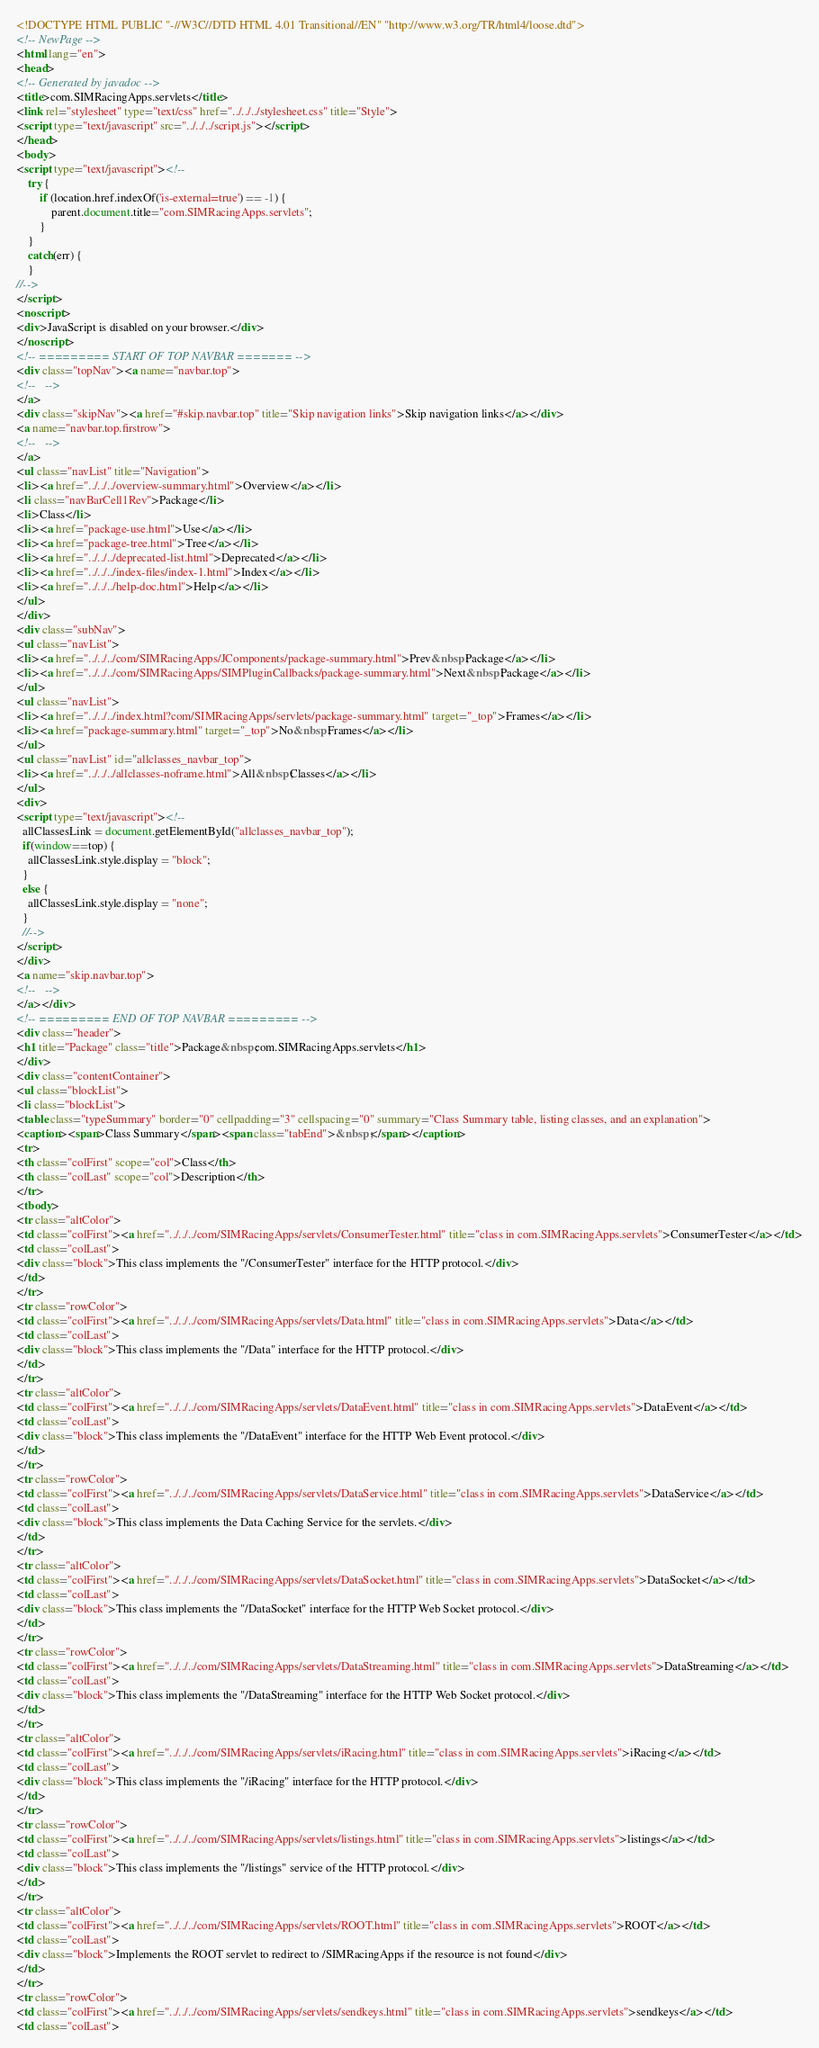Convert code to text. <code><loc_0><loc_0><loc_500><loc_500><_HTML_><!DOCTYPE HTML PUBLIC "-//W3C//DTD HTML 4.01 Transitional//EN" "http://www.w3.org/TR/html4/loose.dtd">
<!-- NewPage -->
<html lang="en">
<head>
<!-- Generated by javadoc -->
<title>com.SIMRacingApps.servlets</title>
<link rel="stylesheet" type="text/css" href="../../../stylesheet.css" title="Style">
<script type="text/javascript" src="../../../script.js"></script>
</head>
<body>
<script type="text/javascript"><!--
    try {
        if (location.href.indexOf('is-external=true') == -1) {
            parent.document.title="com.SIMRacingApps.servlets";
        }
    }
    catch(err) {
    }
//-->
</script>
<noscript>
<div>JavaScript is disabled on your browser.</div>
</noscript>
<!-- ========= START OF TOP NAVBAR ======= -->
<div class="topNav"><a name="navbar.top">
<!--   -->
</a>
<div class="skipNav"><a href="#skip.navbar.top" title="Skip navigation links">Skip navigation links</a></div>
<a name="navbar.top.firstrow">
<!--   -->
</a>
<ul class="navList" title="Navigation">
<li><a href="../../../overview-summary.html">Overview</a></li>
<li class="navBarCell1Rev">Package</li>
<li>Class</li>
<li><a href="package-use.html">Use</a></li>
<li><a href="package-tree.html">Tree</a></li>
<li><a href="../../../deprecated-list.html">Deprecated</a></li>
<li><a href="../../../index-files/index-1.html">Index</a></li>
<li><a href="../../../help-doc.html">Help</a></li>
</ul>
</div>
<div class="subNav">
<ul class="navList">
<li><a href="../../../com/SIMRacingApps/JComponents/package-summary.html">Prev&nbsp;Package</a></li>
<li><a href="../../../com/SIMRacingApps/SIMPluginCallbacks/package-summary.html">Next&nbsp;Package</a></li>
</ul>
<ul class="navList">
<li><a href="../../../index.html?com/SIMRacingApps/servlets/package-summary.html" target="_top">Frames</a></li>
<li><a href="package-summary.html" target="_top">No&nbsp;Frames</a></li>
</ul>
<ul class="navList" id="allclasses_navbar_top">
<li><a href="../../../allclasses-noframe.html">All&nbsp;Classes</a></li>
</ul>
<div>
<script type="text/javascript"><!--
  allClassesLink = document.getElementById("allclasses_navbar_top");
  if(window==top) {
    allClassesLink.style.display = "block";
  }
  else {
    allClassesLink.style.display = "none";
  }
  //-->
</script>
</div>
<a name="skip.navbar.top">
<!--   -->
</a></div>
<!-- ========= END OF TOP NAVBAR ========= -->
<div class="header">
<h1 title="Package" class="title">Package&nbsp;com.SIMRacingApps.servlets</h1>
</div>
<div class="contentContainer">
<ul class="blockList">
<li class="blockList">
<table class="typeSummary" border="0" cellpadding="3" cellspacing="0" summary="Class Summary table, listing classes, and an explanation">
<caption><span>Class Summary</span><span class="tabEnd">&nbsp;</span></caption>
<tr>
<th class="colFirst" scope="col">Class</th>
<th class="colLast" scope="col">Description</th>
</tr>
<tbody>
<tr class="altColor">
<td class="colFirst"><a href="../../../com/SIMRacingApps/servlets/ConsumerTester.html" title="class in com.SIMRacingApps.servlets">ConsumerTester</a></td>
<td class="colLast">
<div class="block">This class implements the "/ConsumerTester" interface for the HTTP protocol.</div>
</td>
</tr>
<tr class="rowColor">
<td class="colFirst"><a href="../../../com/SIMRacingApps/servlets/Data.html" title="class in com.SIMRacingApps.servlets">Data</a></td>
<td class="colLast">
<div class="block">This class implements the "/Data" interface for the HTTP protocol.</div>
</td>
</tr>
<tr class="altColor">
<td class="colFirst"><a href="../../../com/SIMRacingApps/servlets/DataEvent.html" title="class in com.SIMRacingApps.servlets">DataEvent</a></td>
<td class="colLast">
<div class="block">This class implements the "/DataEvent" interface for the HTTP Web Event protocol.</div>
</td>
</tr>
<tr class="rowColor">
<td class="colFirst"><a href="../../../com/SIMRacingApps/servlets/DataService.html" title="class in com.SIMRacingApps.servlets">DataService</a></td>
<td class="colLast">
<div class="block">This class implements the Data Caching Service for the servlets.</div>
</td>
</tr>
<tr class="altColor">
<td class="colFirst"><a href="../../../com/SIMRacingApps/servlets/DataSocket.html" title="class in com.SIMRacingApps.servlets">DataSocket</a></td>
<td class="colLast">
<div class="block">This class implements the "/DataSocket" interface for the HTTP Web Socket protocol.</div>
</td>
</tr>
<tr class="rowColor">
<td class="colFirst"><a href="../../../com/SIMRacingApps/servlets/DataStreaming.html" title="class in com.SIMRacingApps.servlets">DataStreaming</a></td>
<td class="colLast">
<div class="block">This class implements the "/DataStreaming" interface for the HTTP Web Socket protocol.</div>
</td>
</tr>
<tr class="altColor">
<td class="colFirst"><a href="../../../com/SIMRacingApps/servlets/iRacing.html" title="class in com.SIMRacingApps.servlets">iRacing</a></td>
<td class="colLast">
<div class="block">This class implements the "/iRacing" interface for the HTTP protocol.</div>
</td>
</tr>
<tr class="rowColor">
<td class="colFirst"><a href="../../../com/SIMRacingApps/servlets/listings.html" title="class in com.SIMRacingApps.servlets">listings</a></td>
<td class="colLast">
<div class="block">This class implements the "/listings" service of the HTTP protocol.</div>
</td>
</tr>
<tr class="altColor">
<td class="colFirst"><a href="../../../com/SIMRacingApps/servlets/ROOT.html" title="class in com.SIMRacingApps.servlets">ROOT</a></td>
<td class="colLast">
<div class="block">Implements the ROOT servlet to redirect to /SIMRacingApps if the resource is not found</div>
</td>
</tr>
<tr class="rowColor">
<td class="colFirst"><a href="../../../com/SIMRacingApps/servlets/sendkeys.html" title="class in com.SIMRacingApps.servlets">sendkeys</a></td>
<td class="colLast"></code> 